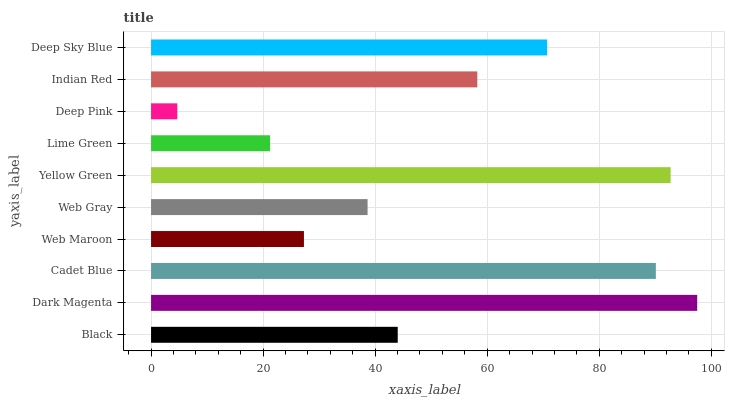Is Deep Pink the minimum?
Answer yes or no. Yes. Is Dark Magenta the maximum?
Answer yes or no. Yes. Is Cadet Blue the minimum?
Answer yes or no. No. Is Cadet Blue the maximum?
Answer yes or no. No. Is Dark Magenta greater than Cadet Blue?
Answer yes or no. Yes. Is Cadet Blue less than Dark Magenta?
Answer yes or no. Yes. Is Cadet Blue greater than Dark Magenta?
Answer yes or no. No. Is Dark Magenta less than Cadet Blue?
Answer yes or no. No. Is Indian Red the high median?
Answer yes or no. Yes. Is Black the low median?
Answer yes or no. Yes. Is Dark Magenta the high median?
Answer yes or no. No. Is Web Gray the low median?
Answer yes or no. No. 